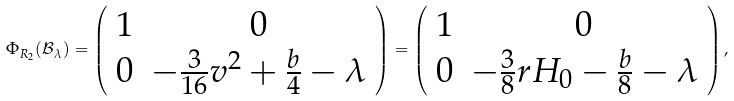<formula> <loc_0><loc_0><loc_500><loc_500>\Phi _ { R _ { 2 } } ( \mathcal { B } _ { \lambda } ) = \left ( \begin{array} { c c } 1 & 0 \\ 0 & - \frac { 3 } { 1 6 } v ^ { 2 } + \frac { b } { 4 } - \lambda \end{array} \right ) = \left ( \begin{array} { c c } 1 & 0 \\ 0 & - \frac { 3 } { 8 } r H _ { 0 } - \frac { b } { 8 } - \lambda \end{array} \right ) ,</formula> 